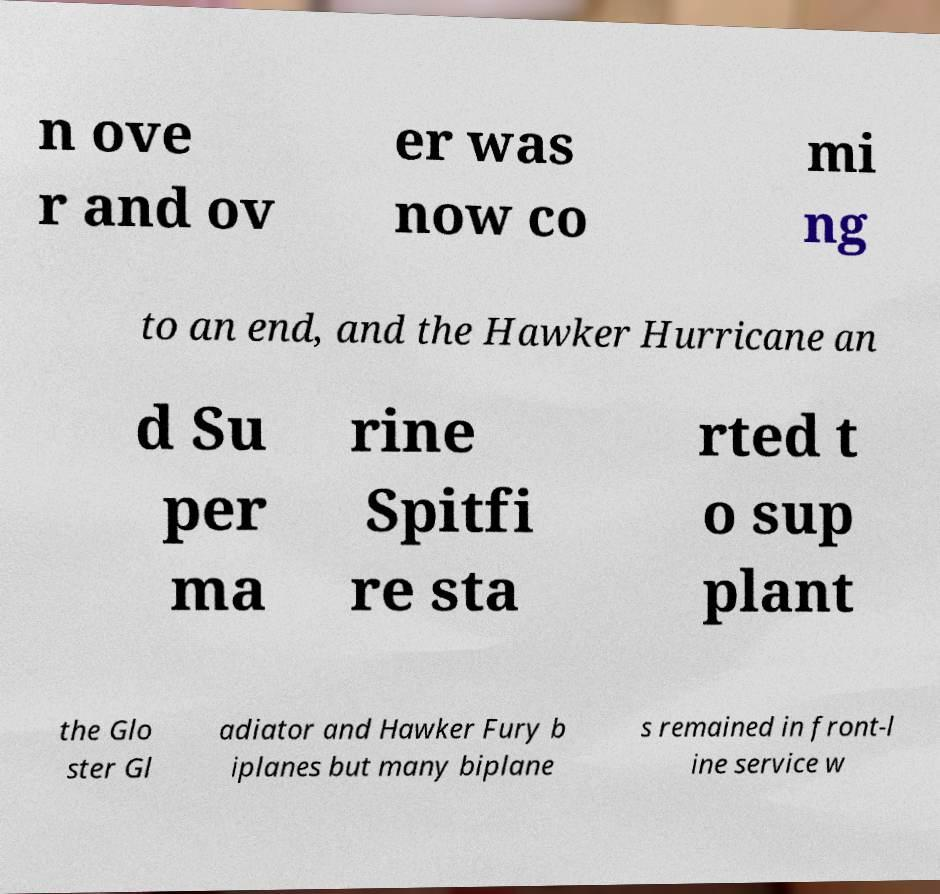There's text embedded in this image that I need extracted. Can you transcribe it verbatim? n ove r and ov er was now co mi ng to an end, and the Hawker Hurricane an d Su per ma rine Spitfi re sta rted t o sup plant the Glo ster Gl adiator and Hawker Fury b iplanes but many biplane s remained in front-l ine service w 